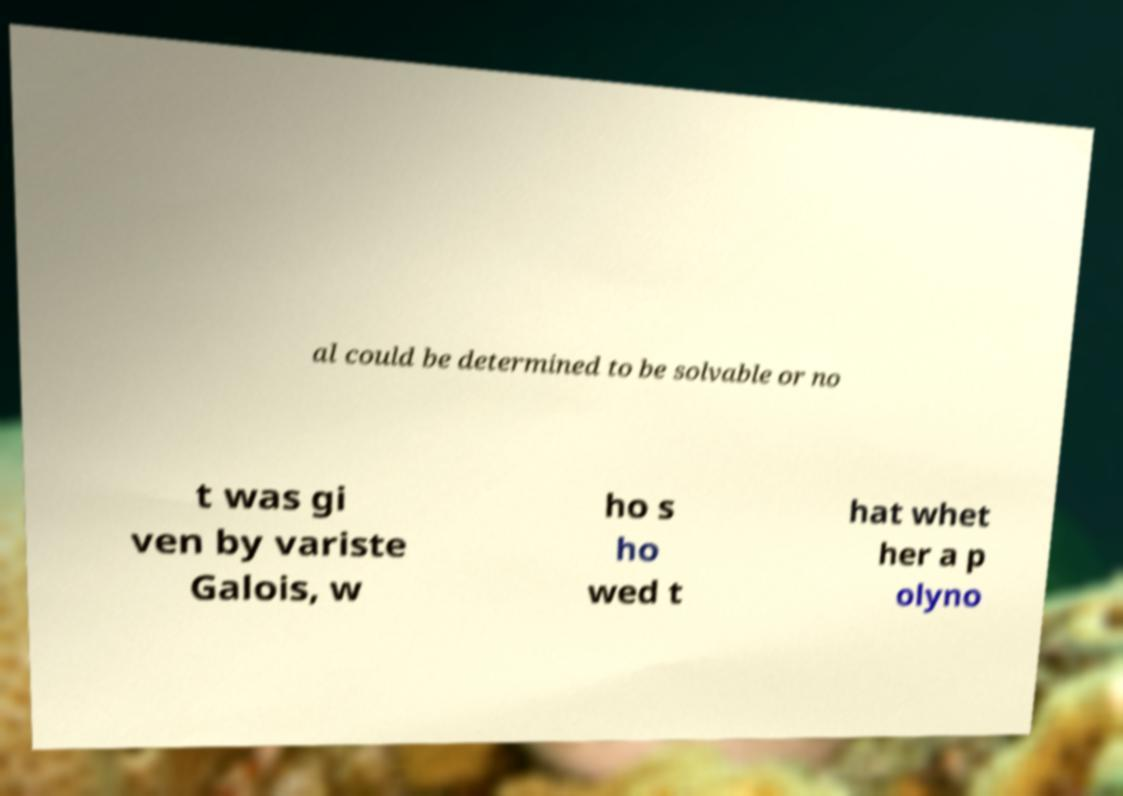There's text embedded in this image that I need extracted. Can you transcribe it verbatim? al could be determined to be solvable or no t was gi ven by variste Galois, w ho s ho wed t hat whet her a p olyno 